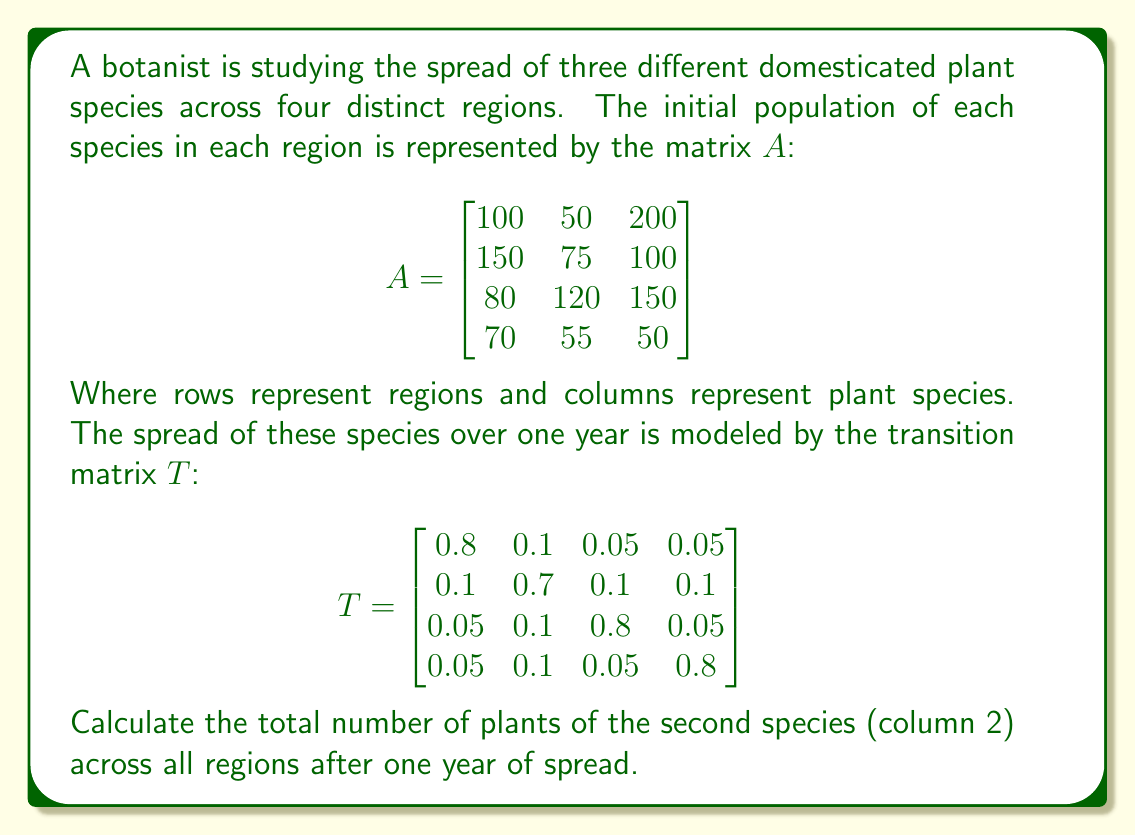Show me your answer to this math problem. To solve this problem, we need to follow these steps:

1) The spread of plants after one year is given by the matrix multiplication $TA$. 

2) Let's perform this multiplication:

   $$TA = \begin{bmatrix}
   0.8 & 0.1 & 0.05 & 0.05 \\
   0.1 & 0.7 & 0.1 & 0.1 \\
   0.05 & 0.1 & 0.8 & 0.05 \\
   0.05 & 0.1 & 0.05 & 0.8
   \end{bmatrix} \begin{bmatrix}
   100 & 50 & 200 \\
   150 & 75 & 100 \\
   80 & 120 & 150 \\
   70 & 55 & 50
   \end{bmatrix}$$

3) Let's focus on the second column of the resulting matrix, as we're interested in the second species:

   $$\begin{aligned}
   \text{Region 1: } & 0.8(50) + 0.1(75) + 0.05(120) + 0.05(55) = 54.75 \\
   \text{Region 2: } & 0.1(50) + 0.7(75) + 0.1(120) + 0.1(55) = 72.5 \\
   \text{Region 3: } & 0.05(50) + 0.1(75) + 0.8(120) + 0.05(55) = 104.75 \\
   \text{Region 4: } & 0.05(50) + 0.1(75) + 0.05(120) + 0.8(55) = 54
   \end{aligned}$$

4) To get the total number of plants of the second species across all regions, we sum these values:

   $54.75 + 72.5 + 104.75 + 54 = 286$

Therefore, after one year, there will be a total of 286 plants of the second species across all regions.
Answer: 286 